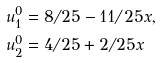<formula> <loc_0><loc_0><loc_500><loc_500>u _ { 1 } ^ { 0 } & = 8 / 2 5 - 1 1 / 2 5 x , \\ u _ { 2 } ^ { 0 } & = 4 / 2 5 + 2 / 2 5 x</formula> 